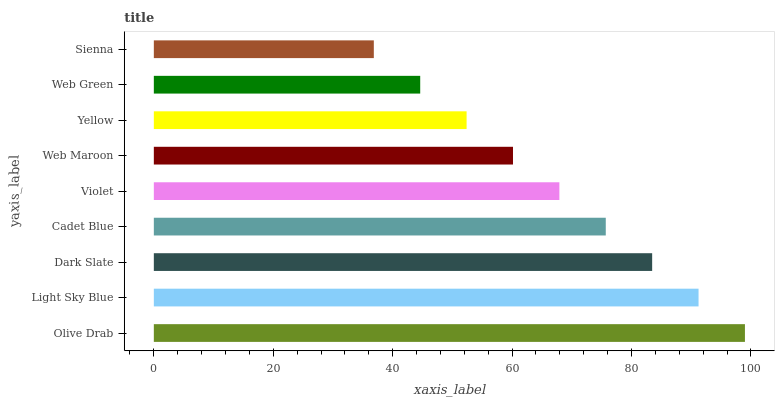Is Sienna the minimum?
Answer yes or no. Yes. Is Olive Drab the maximum?
Answer yes or no. Yes. Is Light Sky Blue the minimum?
Answer yes or no. No. Is Light Sky Blue the maximum?
Answer yes or no. No. Is Olive Drab greater than Light Sky Blue?
Answer yes or no. Yes. Is Light Sky Blue less than Olive Drab?
Answer yes or no. Yes. Is Light Sky Blue greater than Olive Drab?
Answer yes or no. No. Is Olive Drab less than Light Sky Blue?
Answer yes or no. No. Is Violet the high median?
Answer yes or no. Yes. Is Violet the low median?
Answer yes or no. Yes. Is Cadet Blue the high median?
Answer yes or no. No. Is Olive Drab the low median?
Answer yes or no. No. 